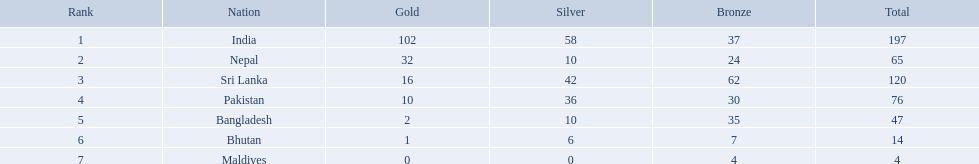What were the total amount won of medals by nations in the 1999 south asian games? 197, 65, 120, 76, 47, 14, 4. Which amount was the lowest? 4. Write the full table. {'header': ['Rank', 'Nation', 'Gold', 'Silver', 'Bronze', 'Total'], 'rows': [['1', 'India', '102', '58', '37', '197'], ['2', 'Nepal', '32', '10', '24', '65'], ['3', 'Sri Lanka', '16', '42', '62', '120'], ['4', 'Pakistan', '10', '36', '30', '76'], ['5', 'Bangladesh', '2', '10', '35', '47'], ['6', 'Bhutan', '1', '6', '7', '14'], ['7', 'Maldives', '0', '0', '4', '4']]} Which nation had this amount? Maldives. What are the nations? India, Nepal, Sri Lanka, Pakistan, Bangladesh, Bhutan, Maldives. Of these, which one has earned the least amount of gold medals? Maldives. How many gold medals were won by the teams? 102, 32, 16, 10, 2, 1, 0. What country won no gold medals? Maldives. Which nations played at the 1999 south asian games? India, Nepal, Sri Lanka, Pakistan, Bangladesh, Bhutan, Maldives. Which country is listed second in the table? Nepal. What was the combined number of medals secured by nations in the 1999 south asian games? 197, 65, 120, 76, 47, 14, 4. Which number was the least? 4. Which nation achieved this number? Maldives. Which countries participated in the 1999 south asian games? India, Nepal, Sri Lanka, Pakistan, Bangladesh, Bhutan, Maldives. Among them, who secured gold medals? India, Nepal, Sri Lanka, Pakistan, Bangladesh, Bhutan. Which country failed to obtain any gold medals? Maldives. What nations participated in the 1999 south asian games? India, Nepal, Sri Lanka, Pakistan, Bangladesh, Bhutan, Maldives. Which among them secured 32 gold medals? Nepal. Which countries took part in the 1999 south asian games? India, Nepal, Sri Lanka, Pakistan, Bangladesh, Bhutan, Maldives. Which one of them won 32 gold medals? Nepal. Parse the full table. {'header': ['Rank', 'Nation', 'Gold', 'Silver', 'Bronze', 'Total'], 'rows': [['1', 'India', '102', '58', '37', '197'], ['2', 'Nepal', '32', '10', '24', '65'], ['3', 'Sri Lanka', '16', '42', '62', '120'], ['4', 'Pakistan', '10', '36', '30', '76'], ['5', 'Bangladesh', '2', '10', '35', '47'], ['6', 'Bhutan', '1', '6', '7', '14'], ['7', 'Maldives', '0', '0', '4', '4']]} How many gold awards were secured by the teams? 102, 32, 16, 10, 2, 1, 0. Which nation didn't win any gold awards? Maldives. What is the number of gold medals obtained by the teams? 102, 32, 16, 10, 2, 1, 0. What nation failed to win a single gold medal? Maldives. Which states earned medals? India, Nepal, Sri Lanka, Pakistan, Bangladesh, Bhutan, Maldives. Which earned the greatest amount? India. Which earned the smallest amount? Maldives. What countries were present at the 1999 south asian games? India, Nepal, Sri Lanka, Pakistan, Bangladesh, Bhutan, Maldives. Which of them obtained 32 gold medals? Nepal. Which nations were part of the 1999 south asian games? India, Nepal, Sri Lanka, Pakistan, Bangladesh, Bhutan, Maldives. Of those, who achieved gold medals? India, Nepal, Sri Lanka, Pakistan, Bangladesh, Bhutan. Which country did not earn any gold medals? Maldives. Can you give me this table in json format? {'header': ['Rank', 'Nation', 'Gold', 'Silver', 'Bronze', 'Total'], 'rows': [['1', 'India', '102', '58', '37', '197'], ['2', 'Nepal', '32', '10', '24', '65'], ['3', 'Sri Lanka', '16', '42', '62', '120'], ['4', 'Pakistan', '10', '36', '30', '76'], ['5', 'Bangladesh', '2', '10', '35', '47'], ['6', 'Bhutan', '1', '6', '7', '14'], ['7', 'Maldives', '0', '0', '4', '4']]} What was the overall sum of medals earned by countries in the 1999 south asian games? 197, 65, 120, 76, 47, 14, 4. Which sum was the smallest? 4. Which country had this sum? Maldives. What are the countries? India, Nepal, Sri Lanka, Pakistan, Bangladesh, Bhutan, Maldives. Among them, which one has obtained the smallest number of gold medals? Maldives. Which countries managed to achieve medals? India, Nepal, Sri Lanka, Pakistan, Bangladesh, Bhutan, Maldives. Which had the highest count? India. Which had the lowest count? Maldives. Which countries earned medals? India, Nepal, Sri Lanka, Pakistan, Bangladesh, Bhutan, Maldives. Which country had the most? India. Which had the least? Maldives. What were the countries present at the 1999 south asian games? India, Nepal, Sri Lanka, Pakistan, Bangladesh, Bhutan, Maldives. Parse the table in full. {'header': ['Rank', 'Nation', 'Gold', 'Silver', 'Bronze', 'Total'], 'rows': [['1', 'India', '102', '58', '37', '197'], ['2', 'Nepal', '32', '10', '24', '65'], ['3', 'Sri Lanka', '16', '42', '62', '120'], ['4', 'Pakistan', '10', '36', '30', '76'], ['5', 'Bangladesh', '2', '10', '35', '47'], ['6', 'Bhutan', '1', '6', '7', '14'], ['7', 'Maldives', '0', '0', '4', '4']]} Out of those, which country claimed 32 gold medals? Nepal. What countries are mentioned in the table? India, Nepal, Sri Lanka, Pakistan, Bangladesh, Bhutan, Maldives. Which one is not india? Nepal, Sri Lanka, Pakistan, Bangladesh, Bhutan, Maldives. Among them, which is the first one? Nepal. 